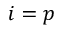Convert formula to latex. <formula><loc_0><loc_0><loc_500><loc_500>i = p</formula> 